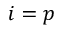Convert formula to latex. <formula><loc_0><loc_0><loc_500><loc_500>i = p</formula> 